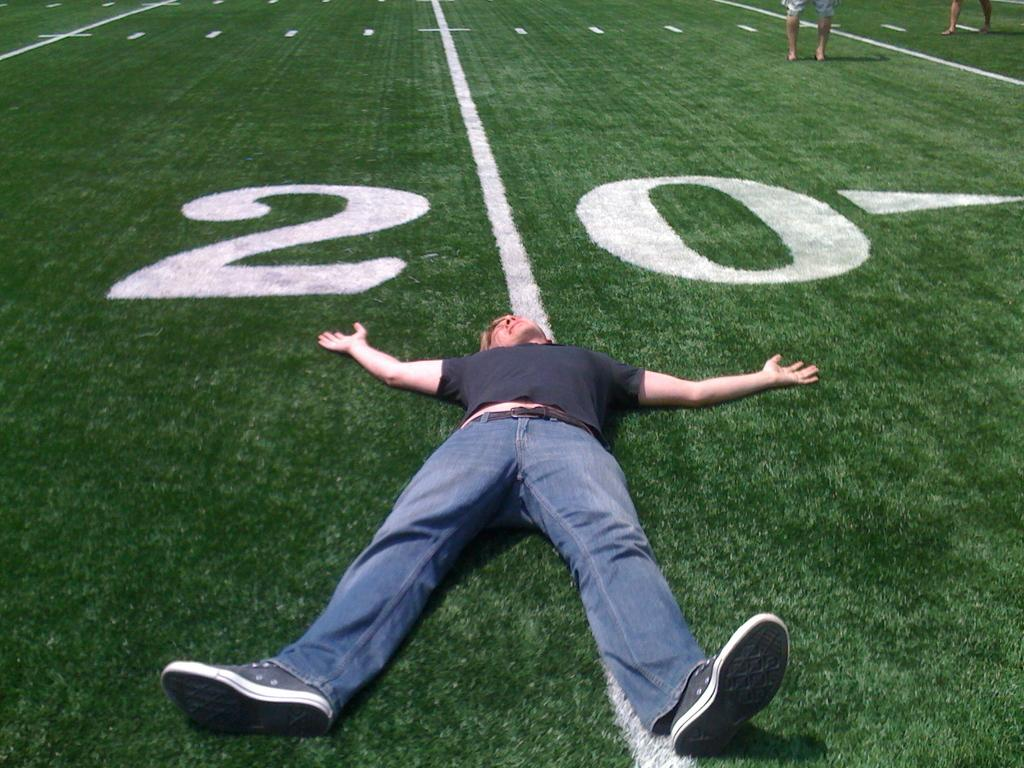What is the man in the image wearing? The man is wearing a t-shirt, trousers, and shoes. What is the man doing in the image? The man is sleeping. What type of surface can be seen in the image? There is grass in the image. Are there any words or letters in the image? Yes, there is text in the image. How many people are visible in the image? There are two people at the top of the image. Can you see the ocean in the image? No, there is no ocean present in the image. What type of stew is the man eating in the image? The man is sleeping, not eating, so there is no stew in the image. 